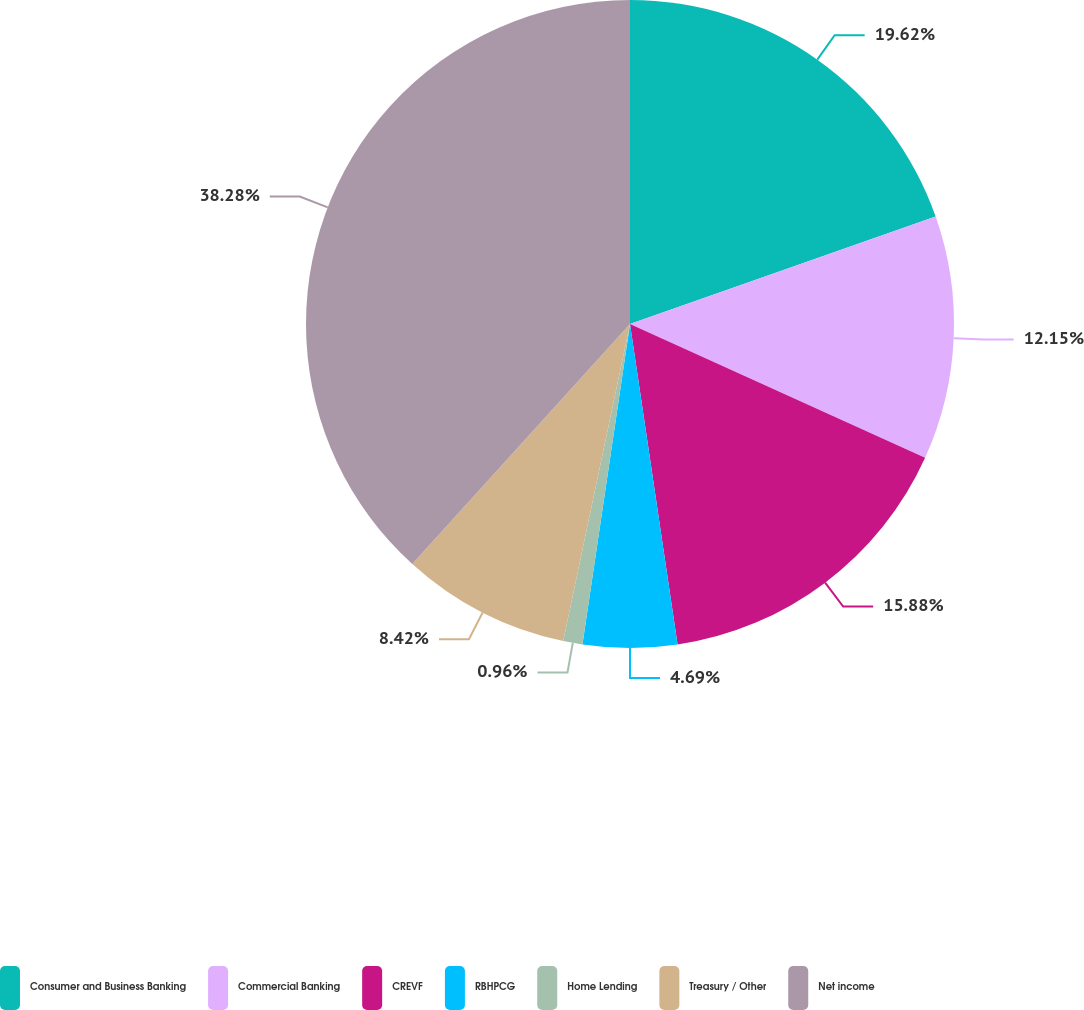Convert chart to OTSL. <chart><loc_0><loc_0><loc_500><loc_500><pie_chart><fcel>Consumer and Business Banking<fcel>Commercial Banking<fcel>CREVF<fcel>RBHPCG<fcel>Home Lending<fcel>Treasury / Other<fcel>Net income<nl><fcel>19.62%<fcel>12.15%<fcel>15.88%<fcel>4.69%<fcel>0.96%<fcel>8.42%<fcel>38.27%<nl></chart> 